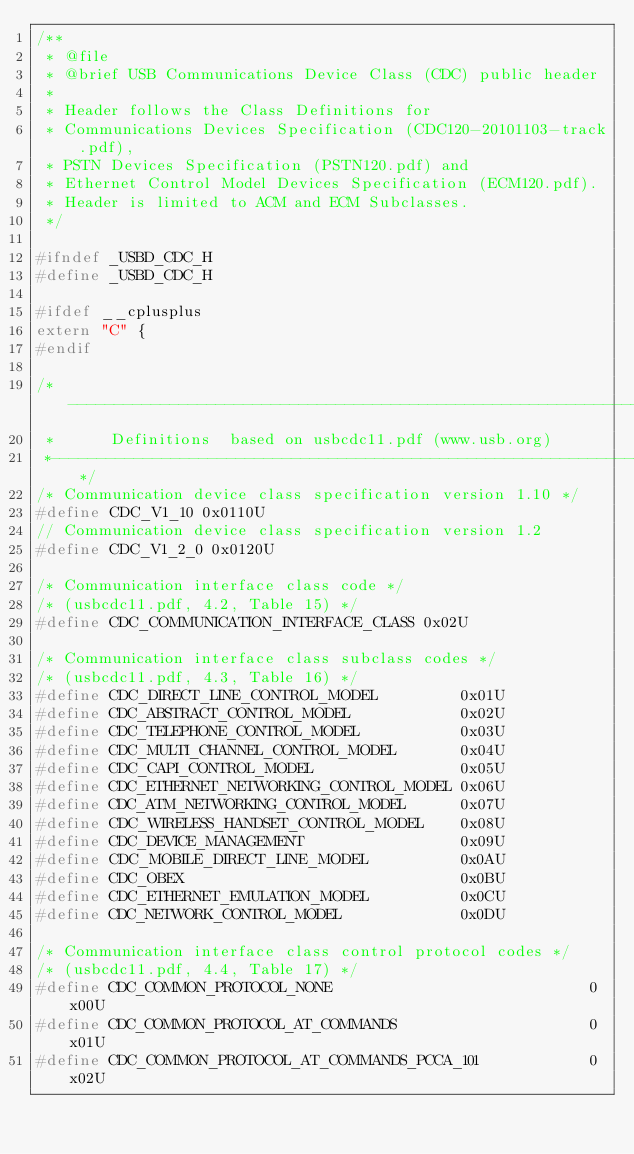<code> <loc_0><loc_0><loc_500><loc_500><_C_>/**
 * @file
 * @brief USB Communications Device Class (CDC) public header
 *
 * Header follows the Class Definitions for
 * Communications Devices Specification (CDC120-20101103-track.pdf),
 * PSTN Devices Specification (PSTN120.pdf) and
 * Ethernet Control Model Devices Specification (ECM120.pdf).
 * Header is limited to ACM and ECM Subclasses.
 */

#ifndef _USBD_CDC_H
#define _USBD_CDC_H

#ifdef __cplusplus
extern "C" {
#endif

/*------------------------------------------------------------------------------
 *      Definitions  based on usbcdc11.pdf (www.usb.org)
 *----------------------------------------------------------------------------*/
/* Communication device class specification version 1.10 */
#define CDC_V1_10 0x0110U
// Communication device class specification version 1.2
#define CDC_V1_2_0 0x0120U

/* Communication interface class code */
/* (usbcdc11.pdf, 4.2, Table 15) */
#define CDC_COMMUNICATION_INTERFACE_CLASS 0x02U

/* Communication interface class subclass codes */
/* (usbcdc11.pdf, 4.3, Table 16) */
#define CDC_DIRECT_LINE_CONTROL_MODEL         0x01U
#define CDC_ABSTRACT_CONTROL_MODEL            0x02U
#define CDC_TELEPHONE_CONTROL_MODEL           0x03U
#define CDC_MULTI_CHANNEL_CONTROL_MODEL       0x04U
#define CDC_CAPI_CONTROL_MODEL                0x05U
#define CDC_ETHERNET_NETWORKING_CONTROL_MODEL 0x06U
#define CDC_ATM_NETWORKING_CONTROL_MODEL      0x07U
#define CDC_WIRELESS_HANDSET_CONTROL_MODEL    0x08U
#define CDC_DEVICE_MANAGEMENT                 0x09U
#define CDC_MOBILE_DIRECT_LINE_MODEL          0x0AU
#define CDC_OBEX                              0x0BU
#define CDC_ETHERNET_EMULATION_MODEL          0x0CU
#define CDC_NETWORK_CONTROL_MODEL             0x0DU

/* Communication interface class control protocol codes */
/* (usbcdc11.pdf, 4.4, Table 17) */
#define CDC_COMMON_PROTOCOL_NONE                            0x00U
#define CDC_COMMON_PROTOCOL_AT_COMMANDS                     0x01U
#define CDC_COMMON_PROTOCOL_AT_COMMANDS_PCCA_101            0x02U</code> 